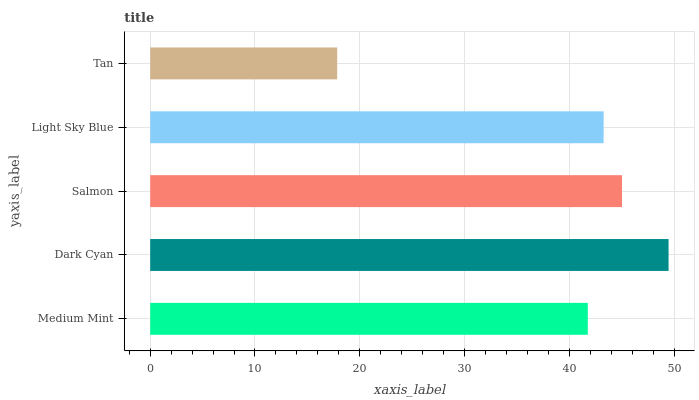Is Tan the minimum?
Answer yes or no. Yes. Is Dark Cyan the maximum?
Answer yes or no. Yes. Is Salmon the minimum?
Answer yes or no. No. Is Salmon the maximum?
Answer yes or no. No. Is Dark Cyan greater than Salmon?
Answer yes or no. Yes. Is Salmon less than Dark Cyan?
Answer yes or no. Yes. Is Salmon greater than Dark Cyan?
Answer yes or no. No. Is Dark Cyan less than Salmon?
Answer yes or no. No. Is Light Sky Blue the high median?
Answer yes or no. Yes. Is Light Sky Blue the low median?
Answer yes or no. Yes. Is Dark Cyan the high median?
Answer yes or no. No. Is Tan the low median?
Answer yes or no. No. 